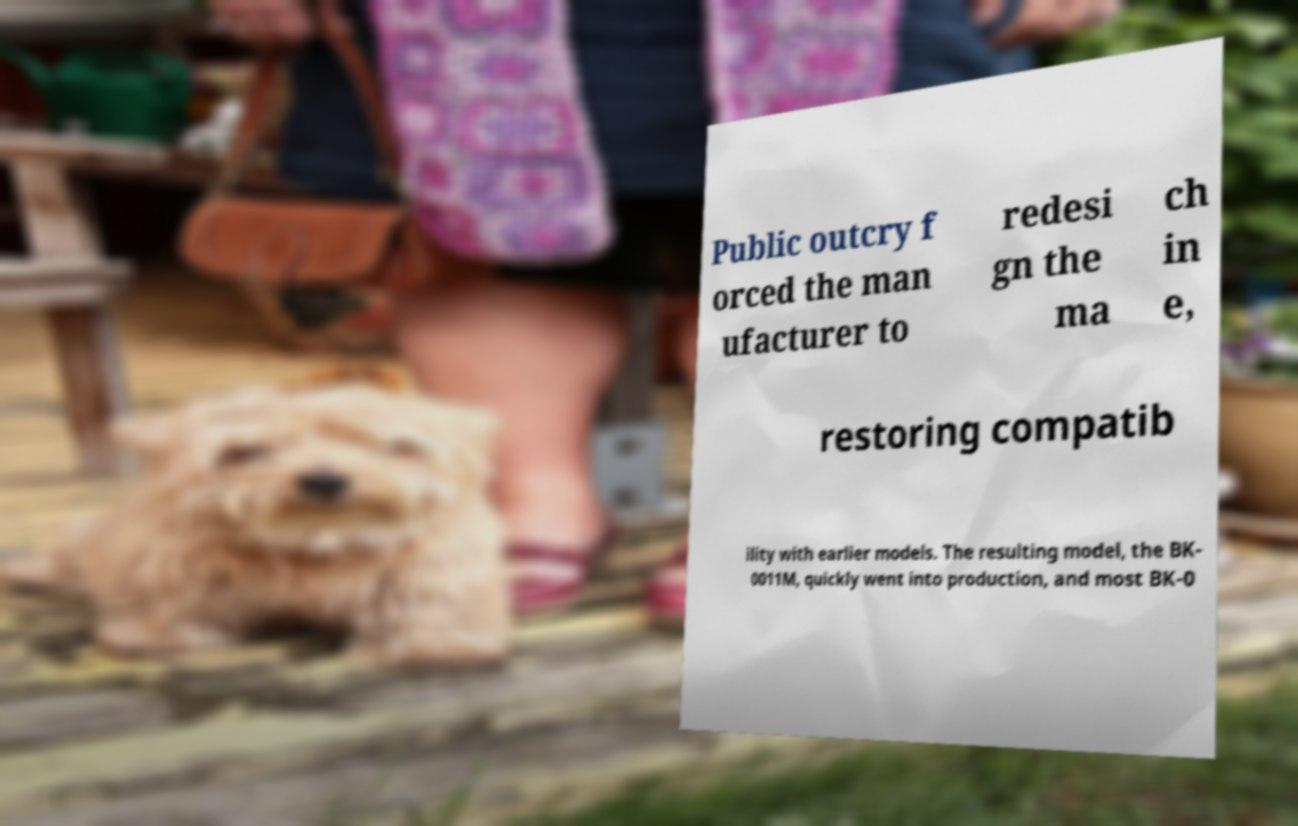Please identify and transcribe the text found in this image. Public outcry f orced the man ufacturer to redesi gn the ma ch in e, restoring compatib ility with earlier models. The resulting model, the BK- 0011M, quickly went into production, and most BK-0 